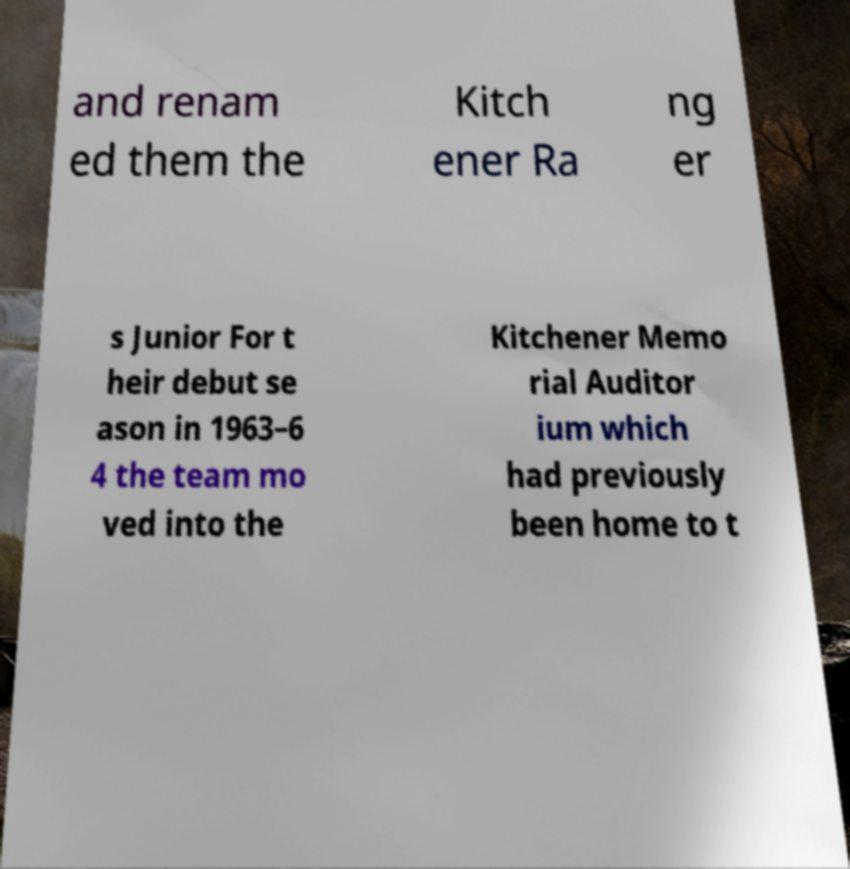Could you extract and type out the text from this image? and renam ed them the Kitch ener Ra ng er s Junior For t heir debut se ason in 1963–6 4 the team mo ved into the Kitchener Memo rial Auditor ium which had previously been home to t 